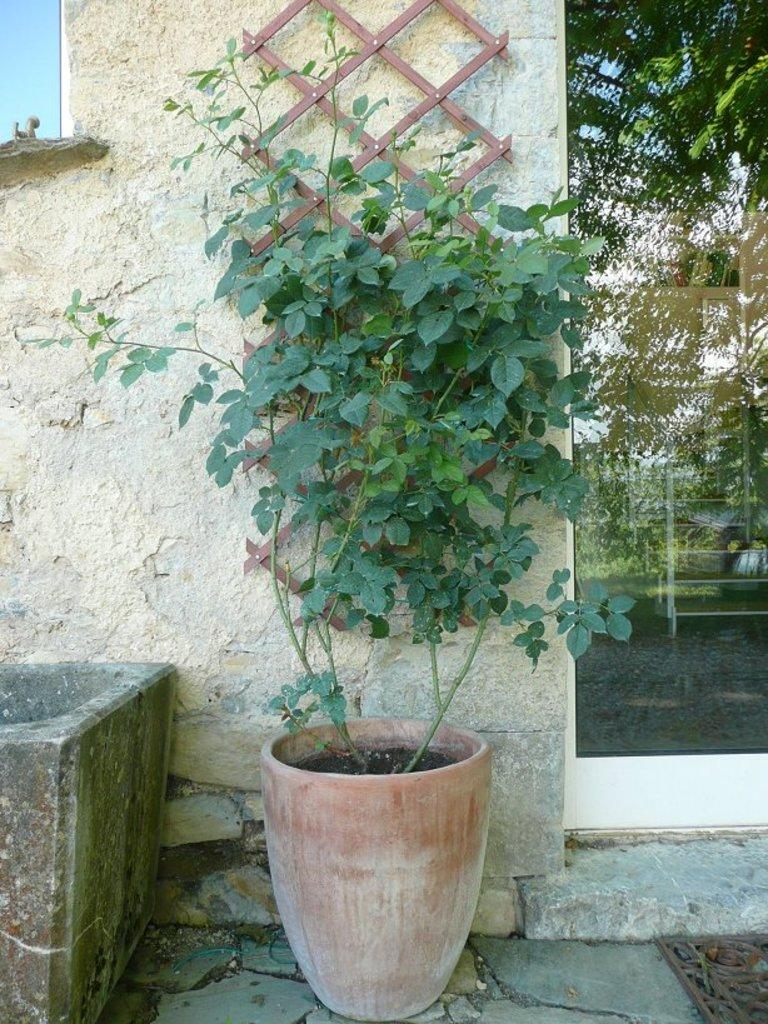What is placed in front of the wall in the image? There is a wooden mesh and a plant in front of the wall. What is the glass beside the wall used for? The glass beside the wall reflects a tree. What can be seen through the glass? There is a rack visible through the glass. What statement does your aunt make about the pencil in the image? There is no pencil or aunt present in the image, so it is not possible to answer that question. 